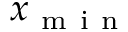Convert formula to latex. <formula><loc_0><loc_0><loc_500><loc_500>x _ { m i n }</formula> 